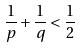Convert formula to latex. <formula><loc_0><loc_0><loc_500><loc_500>\frac { 1 } { p } + \frac { 1 } { q } < \frac { 1 } { 2 }</formula> 